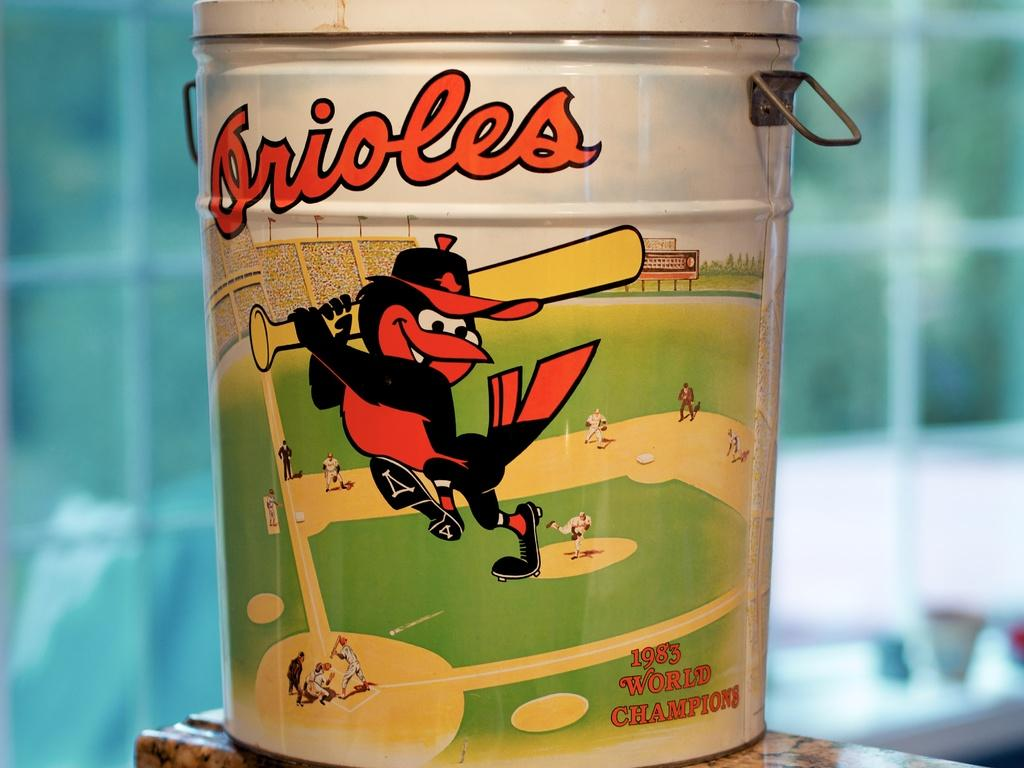<image>
Summarize the visual content of the image. The Orioles container has a big cartoon Oriole bird playing baseball with the team, and 1983 WORLD CHAMPIONS on it too. 